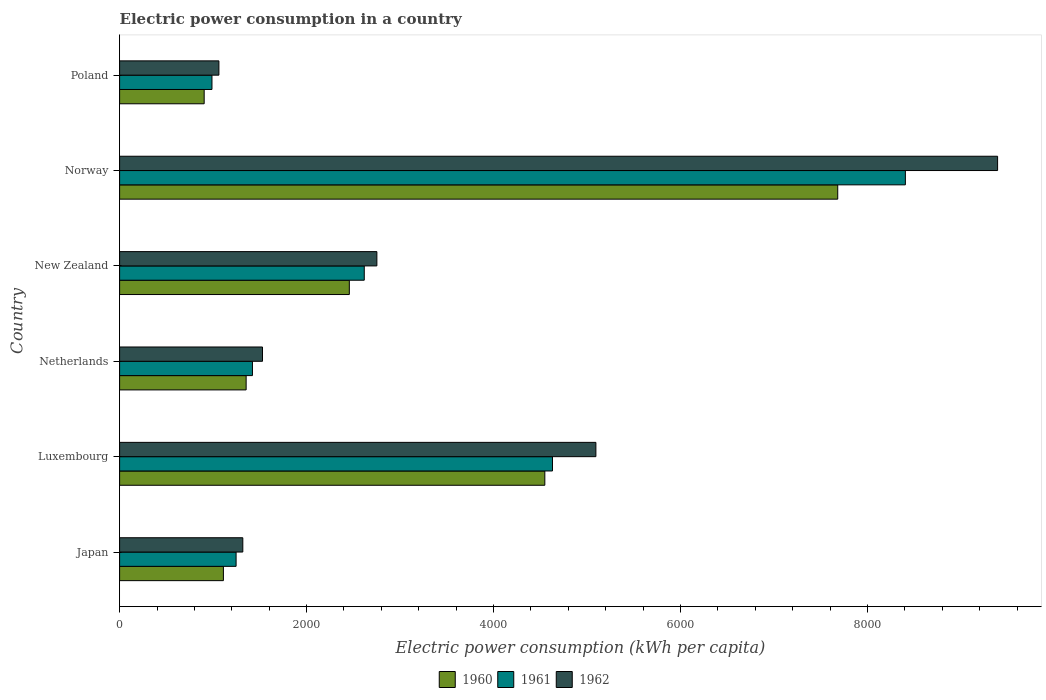How many groups of bars are there?
Give a very brief answer. 6. How many bars are there on the 5th tick from the top?
Keep it short and to the point. 3. How many bars are there on the 4th tick from the bottom?
Your answer should be compact. 3. What is the label of the 4th group of bars from the top?
Offer a very short reply. Netherlands. What is the electric power consumption in in 1960 in New Zealand?
Your answer should be very brief. 2457.21. Across all countries, what is the maximum electric power consumption in in 1960?
Provide a short and direct response. 7681.14. Across all countries, what is the minimum electric power consumption in in 1962?
Provide a short and direct response. 1062.18. What is the total electric power consumption in in 1960 in the graph?
Provide a short and direct response. 1.81e+04. What is the difference between the electric power consumption in in 1960 in Japan and that in Netherlands?
Offer a very short reply. -243.14. What is the difference between the electric power consumption in in 1962 in Luxembourg and the electric power consumption in in 1960 in Norway?
Make the answer very short. -2586.83. What is the average electric power consumption in in 1960 per country?
Your response must be concise. 3009.13. What is the difference between the electric power consumption in in 1961 and electric power consumption in in 1960 in Norway?
Offer a terse response. 723.48. In how many countries, is the electric power consumption in in 1962 greater than 3600 kWh per capita?
Offer a very short reply. 2. What is the ratio of the electric power consumption in in 1962 in Japan to that in Luxembourg?
Keep it short and to the point. 0.26. Is the electric power consumption in in 1961 in Netherlands less than that in New Zealand?
Provide a succinct answer. Yes. What is the difference between the highest and the second highest electric power consumption in in 1960?
Keep it short and to the point. 3132.94. What is the difference between the highest and the lowest electric power consumption in in 1962?
Make the answer very short. 8328.8. What does the 2nd bar from the top in Netherlands represents?
Your answer should be very brief. 1961. What does the 2nd bar from the bottom in Norway represents?
Your answer should be compact. 1961. How many countries are there in the graph?
Your answer should be compact. 6. Where does the legend appear in the graph?
Provide a succinct answer. Bottom center. What is the title of the graph?
Make the answer very short. Electric power consumption in a country. Does "1999" appear as one of the legend labels in the graph?
Your answer should be compact. No. What is the label or title of the X-axis?
Provide a short and direct response. Electric power consumption (kWh per capita). What is the Electric power consumption (kWh per capita) of 1960 in Japan?
Make the answer very short. 1110.26. What is the Electric power consumption (kWh per capita) of 1961 in Japan?
Your response must be concise. 1246.01. What is the Electric power consumption (kWh per capita) in 1962 in Japan?
Ensure brevity in your answer.  1317.93. What is the Electric power consumption (kWh per capita) of 1960 in Luxembourg?
Make the answer very short. 4548.21. What is the Electric power consumption (kWh per capita) in 1961 in Luxembourg?
Give a very brief answer. 4630.02. What is the Electric power consumption (kWh per capita) in 1962 in Luxembourg?
Offer a very short reply. 5094.31. What is the Electric power consumption (kWh per capita) in 1960 in Netherlands?
Keep it short and to the point. 1353.4. What is the Electric power consumption (kWh per capita) of 1961 in Netherlands?
Provide a short and direct response. 1421.03. What is the Electric power consumption (kWh per capita) of 1962 in Netherlands?
Keep it short and to the point. 1528.5. What is the Electric power consumption (kWh per capita) in 1960 in New Zealand?
Keep it short and to the point. 2457.21. What is the Electric power consumption (kWh per capita) of 1961 in New Zealand?
Your response must be concise. 2616.85. What is the Electric power consumption (kWh per capita) of 1962 in New Zealand?
Make the answer very short. 2751.81. What is the Electric power consumption (kWh per capita) in 1960 in Norway?
Your response must be concise. 7681.14. What is the Electric power consumption (kWh per capita) in 1961 in Norway?
Offer a very short reply. 8404.62. What is the Electric power consumption (kWh per capita) of 1962 in Norway?
Your answer should be very brief. 9390.98. What is the Electric power consumption (kWh per capita) of 1960 in Poland?
Offer a very short reply. 904.57. What is the Electric power consumption (kWh per capita) in 1961 in Poland?
Your response must be concise. 987.92. What is the Electric power consumption (kWh per capita) in 1962 in Poland?
Provide a succinct answer. 1062.18. Across all countries, what is the maximum Electric power consumption (kWh per capita) of 1960?
Offer a terse response. 7681.14. Across all countries, what is the maximum Electric power consumption (kWh per capita) of 1961?
Your response must be concise. 8404.62. Across all countries, what is the maximum Electric power consumption (kWh per capita) in 1962?
Your response must be concise. 9390.98. Across all countries, what is the minimum Electric power consumption (kWh per capita) of 1960?
Give a very brief answer. 904.57. Across all countries, what is the minimum Electric power consumption (kWh per capita) of 1961?
Make the answer very short. 987.92. Across all countries, what is the minimum Electric power consumption (kWh per capita) of 1962?
Your answer should be compact. 1062.18. What is the total Electric power consumption (kWh per capita) in 1960 in the graph?
Make the answer very short. 1.81e+04. What is the total Electric power consumption (kWh per capita) in 1961 in the graph?
Offer a very short reply. 1.93e+04. What is the total Electric power consumption (kWh per capita) of 1962 in the graph?
Provide a short and direct response. 2.11e+04. What is the difference between the Electric power consumption (kWh per capita) in 1960 in Japan and that in Luxembourg?
Keep it short and to the point. -3437.94. What is the difference between the Electric power consumption (kWh per capita) in 1961 in Japan and that in Luxembourg?
Keep it short and to the point. -3384.01. What is the difference between the Electric power consumption (kWh per capita) of 1962 in Japan and that in Luxembourg?
Offer a very short reply. -3776.38. What is the difference between the Electric power consumption (kWh per capita) of 1960 in Japan and that in Netherlands?
Keep it short and to the point. -243.14. What is the difference between the Electric power consumption (kWh per capita) in 1961 in Japan and that in Netherlands?
Ensure brevity in your answer.  -175.02. What is the difference between the Electric power consumption (kWh per capita) in 1962 in Japan and that in Netherlands?
Your answer should be very brief. -210.57. What is the difference between the Electric power consumption (kWh per capita) in 1960 in Japan and that in New Zealand?
Keep it short and to the point. -1346.94. What is the difference between the Electric power consumption (kWh per capita) of 1961 in Japan and that in New Zealand?
Your answer should be very brief. -1370.84. What is the difference between the Electric power consumption (kWh per capita) in 1962 in Japan and that in New Zealand?
Offer a terse response. -1433.88. What is the difference between the Electric power consumption (kWh per capita) of 1960 in Japan and that in Norway?
Make the answer very short. -6570.88. What is the difference between the Electric power consumption (kWh per capita) in 1961 in Japan and that in Norway?
Your answer should be very brief. -7158.61. What is the difference between the Electric power consumption (kWh per capita) in 1962 in Japan and that in Norway?
Offer a very short reply. -8073.05. What is the difference between the Electric power consumption (kWh per capita) of 1960 in Japan and that in Poland?
Provide a short and direct response. 205.7. What is the difference between the Electric power consumption (kWh per capita) in 1961 in Japan and that in Poland?
Keep it short and to the point. 258.09. What is the difference between the Electric power consumption (kWh per capita) in 1962 in Japan and that in Poland?
Your answer should be very brief. 255.75. What is the difference between the Electric power consumption (kWh per capita) in 1960 in Luxembourg and that in Netherlands?
Ensure brevity in your answer.  3194.81. What is the difference between the Electric power consumption (kWh per capita) in 1961 in Luxembourg and that in Netherlands?
Give a very brief answer. 3208.99. What is the difference between the Electric power consumption (kWh per capita) in 1962 in Luxembourg and that in Netherlands?
Provide a short and direct response. 3565.81. What is the difference between the Electric power consumption (kWh per capita) of 1960 in Luxembourg and that in New Zealand?
Give a very brief answer. 2091. What is the difference between the Electric power consumption (kWh per capita) of 1961 in Luxembourg and that in New Zealand?
Your answer should be very brief. 2013.17. What is the difference between the Electric power consumption (kWh per capita) in 1962 in Luxembourg and that in New Zealand?
Your answer should be very brief. 2342.5. What is the difference between the Electric power consumption (kWh per capita) of 1960 in Luxembourg and that in Norway?
Your answer should be very brief. -3132.94. What is the difference between the Electric power consumption (kWh per capita) in 1961 in Luxembourg and that in Norway?
Provide a succinct answer. -3774.6. What is the difference between the Electric power consumption (kWh per capita) of 1962 in Luxembourg and that in Norway?
Offer a very short reply. -4296.67. What is the difference between the Electric power consumption (kWh per capita) of 1960 in Luxembourg and that in Poland?
Provide a short and direct response. 3643.64. What is the difference between the Electric power consumption (kWh per capita) of 1961 in Luxembourg and that in Poland?
Give a very brief answer. 3642.11. What is the difference between the Electric power consumption (kWh per capita) of 1962 in Luxembourg and that in Poland?
Give a very brief answer. 4032.13. What is the difference between the Electric power consumption (kWh per capita) of 1960 in Netherlands and that in New Zealand?
Make the answer very short. -1103.81. What is the difference between the Electric power consumption (kWh per capita) in 1961 in Netherlands and that in New Zealand?
Offer a very short reply. -1195.82. What is the difference between the Electric power consumption (kWh per capita) of 1962 in Netherlands and that in New Zealand?
Ensure brevity in your answer.  -1223.31. What is the difference between the Electric power consumption (kWh per capita) in 1960 in Netherlands and that in Norway?
Your response must be concise. -6327.74. What is the difference between the Electric power consumption (kWh per capita) in 1961 in Netherlands and that in Norway?
Your answer should be compact. -6983.59. What is the difference between the Electric power consumption (kWh per capita) of 1962 in Netherlands and that in Norway?
Offer a very short reply. -7862.48. What is the difference between the Electric power consumption (kWh per capita) of 1960 in Netherlands and that in Poland?
Your response must be concise. 448.83. What is the difference between the Electric power consumption (kWh per capita) in 1961 in Netherlands and that in Poland?
Offer a very short reply. 433.11. What is the difference between the Electric power consumption (kWh per capita) in 1962 in Netherlands and that in Poland?
Make the answer very short. 466.32. What is the difference between the Electric power consumption (kWh per capita) in 1960 in New Zealand and that in Norway?
Your answer should be compact. -5223.94. What is the difference between the Electric power consumption (kWh per capita) in 1961 in New Zealand and that in Norway?
Keep it short and to the point. -5787.77. What is the difference between the Electric power consumption (kWh per capita) of 1962 in New Zealand and that in Norway?
Offer a terse response. -6639.17. What is the difference between the Electric power consumption (kWh per capita) of 1960 in New Zealand and that in Poland?
Make the answer very short. 1552.64. What is the difference between the Electric power consumption (kWh per capita) of 1961 in New Zealand and that in Poland?
Make the answer very short. 1628.93. What is the difference between the Electric power consumption (kWh per capita) of 1962 in New Zealand and that in Poland?
Give a very brief answer. 1689.64. What is the difference between the Electric power consumption (kWh per capita) in 1960 in Norway and that in Poland?
Give a very brief answer. 6776.58. What is the difference between the Electric power consumption (kWh per capita) in 1961 in Norway and that in Poland?
Your answer should be compact. 7416.7. What is the difference between the Electric power consumption (kWh per capita) of 1962 in Norway and that in Poland?
Ensure brevity in your answer.  8328.8. What is the difference between the Electric power consumption (kWh per capita) in 1960 in Japan and the Electric power consumption (kWh per capita) in 1961 in Luxembourg?
Offer a very short reply. -3519.76. What is the difference between the Electric power consumption (kWh per capita) of 1960 in Japan and the Electric power consumption (kWh per capita) of 1962 in Luxembourg?
Provide a short and direct response. -3984.05. What is the difference between the Electric power consumption (kWh per capita) in 1961 in Japan and the Electric power consumption (kWh per capita) in 1962 in Luxembourg?
Offer a very short reply. -3848.3. What is the difference between the Electric power consumption (kWh per capita) of 1960 in Japan and the Electric power consumption (kWh per capita) of 1961 in Netherlands?
Your answer should be very brief. -310.77. What is the difference between the Electric power consumption (kWh per capita) in 1960 in Japan and the Electric power consumption (kWh per capita) in 1962 in Netherlands?
Your answer should be very brief. -418.24. What is the difference between the Electric power consumption (kWh per capita) of 1961 in Japan and the Electric power consumption (kWh per capita) of 1962 in Netherlands?
Your answer should be very brief. -282.49. What is the difference between the Electric power consumption (kWh per capita) of 1960 in Japan and the Electric power consumption (kWh per capita) of 1961 in New Zealand?
Keep it short and to the point. -1506.59. What is the difference between the Electric power consumption (kWh per capita) of 1960 in Japan and the Electric power consumption (kWh per capita) of 1962 in New Zealand?
Offer a terse response. -1641.55. What is the difference between the Electric power consumption (kWh per capita) of 1961 in Japan and the Electric power consumption (kWh per capita) of 1962 in New Zealand?
Keep it short and to the point. -1505.8. What is the difference between the Electric power consumption (kWh per capita) of 1960 in Japan and the Electric power consumption (kWh per capita) of 1961 in Norway?
Provide a short and direct response. -7294.36. What is the difference between the Electric power consumption (kWh per capita) of 1960 in Japan and the Electric power consumption (kWh per capita) of 1962 in Norway?
Provide a succinct answer. -8280.71. What is the difference between the Electric power consumption (kWh per capita) in 1961 in Japan and the Electric power consumption (kWh per capita) in 1962 in Norway?
Offer a very short reply. -8144.97. What is the difference between the Electric power consumption (kWh per capita) in 1960 in Japan and the Electric power consumption (kWh per capita) in 1961 in Poland?
Give a very brief answer. 122.34. What is the difference between the Electric power consumption (kWh per capita) in 1960 in Japan and the Electric power consumption (kWh per capita) in 1962 in Poland?
Your response must be concise. 48.09. What is the difference between the Electric power consumption (kWh per capita) of 1961 in Japan and the Electric power consumption (kWh per capita) of 1962 in Poland?
Offer a very short reply. 183.83. What is the difference between the Electric power consumption (kWh per capita) in 1960 in Luxembourg and the Electric power consumption (kWh per capita) in 1961 in Netherlands?
Offer a terse response. 3127.17. What is the difference between the Electric power consumption (kWh per capita) in 1960 in Luxembourg and the Electric power consumption (kWh per capita) in 1962 in Netherlands?
Give a very brief answer. 3019.7. What is the difference between the Electric power consumption (kWh per capita) in 1961 in Luxembourg and the Electric power consumption (kWh per capita) in 1962 in Netherlands?
Ensure brevity in your answer.  3101.52. What is the difference between the Electric power consumption (kWh per capita) in 1960 in Luxembourg and the Electric power consumption (kWh per capita) in 1961 in New Zealand?
Your response must be concise. 1931.35. What is the difference between the Electric power consumption (kWh per capita) of 1960 in Luxembourg and the Electric power consumption (kWh per capita) of 1962 in New Zealand?
Provide a short and direct response. 1796.39. What is the difference between the Electric power consumption (kWh per capita) of 1961 in Luxembourg and the Electric power consumption (kWh per capita) of 1962 in New Zealand?
Your response must be concise. 1878.21. What is the difference between the Electric power consumption (kWh per capita) in 1960 in Luxembourg and the Electric power consumption (kWh per capita) in 1961 in Norway?
Provide a short and direct response. -3856.42. What is the difference between the Electric power consumption (kWh per capita) in 1960 in Luxembourg and the Electric power consumption (kWh per capita) in 1962 in Norway?
Provide a short and direct response. -4842.77. What is the difference between the Electric power consumption (kWh per capita) of 1961 in Luxembourg and the Electric power consumption (kWh per capita) of 1962 in Norway?
Make the answer very short. -4760.95. What is the difference between the Electric power consumption (kWh per capita) in 1960 in Luxembourg and the Electric power consumption (kWh per capita) in 1961 in Poland?
Offer a terse response. 3560.29. What is the difference between the Electric power consumption (kWh per capita) in 1960 in Luxembourg and the Electric power consumption (kWh per capita) in 1962 in Poland?
Make the answer very short. 3486.03. What is the difference between the Electric power consumption (kWh per capita) in 1961 in Luxembourg and the Electric power consumption (kWh per capita) in 1962 in Poland?
Your answer should be compact. 3567.85. What is the difference between the Electric power consumption (kWh per capita) of 1960 in Netherlands and the Electric power consumption (kWh per capita) of 1961 in New Zealand?
Ensure brevity in your answer.  -1263.45. What is the difference between the Electric power consumption (kWh per capita) in 1960 in Netherlands and the Electric power consumption (kWh per capita) in 1962 in New Zealand?
Provide a short and direct response. -1398.41. What is the difference between the Electric power consumption (kWh per capita) in 1961 in Netherlands and the Electric power consumption (kWh per capita) in 1962 in New Zealand?
Offer a very short reply. -1330.78. What is the difference between the Electric power consumption (kWh per capita) of 1960 in Netherlands and the Electric power consumption (kWh per capita) of 1961 in Norway?
Offer a very short reply. -7051.22. What is the difference between the Electric power consumption (kWh per capita) of 1960 in Netherlands and the Electric power consumption (kWh per capita) of 1962 in Norway?
Offer a very short reply. -8037.58. What is the difference between the Electric power consumption (kWh per capita) in 1961 in Netherlands and the Electric power consumption (kWh per capita) in 1962 in Norway?
Make the answer very short. -7969.94. What is the difference between the Electric power consumption (kWh per capita) in 1960 in Netherlands and the Electric power consumption (kWh per capita) in 1961 in Poland?
Your response must be concise. 365.48. What is the difference between the Electric power consumption (kWh per capita) of 1960 in Netherlands and the Electric power consumption (kWh per capita) of 1962 in Poland?
Give a very brief answer. 291.22. What is the difference between the Electric power consumption (kWh per capita) of 1961 in Netherlands and the Electric power consumption (kWh per capita) of 1962 in Poland?
Offer a very short reply. 358.86. What is the difference between the Electric power consumption (kWh per capita) of 1960 in New Zealand and the Electric power consumption (kWh per capita) of 1961 in Norway?
Give a very brief answer. -5947.42. What is the difference between the Electric power consumption (kWh per capita) of 1960 in New Zealand and the Electric power consumption (kWh per capita) of 1962 in Norway?
Offer a very short reply. -6933.77. What is the difference between the Electric power consumption (kWh per capita) in 1961 in New Zealand and the Electric power consumption (kWh per capita) in 1962 in Norway?
Your answer should be compact. -6774.12. What is the difference between the Electric power consumption (kWh per capita) of 1960 in New Zealand and the Electric power consumption (kWh per capita) of 1961 in Poland?
Ensure brevity in your answer.  1469.29. What is the difference between the Electric power consumption (kWh per capita) of 1960 in New Zealand and the Electric power consumption (kWh per capita) of 1962 in Poland?
Ensure brevity in your answer.  1395.03. What is the difference between the Electric power consumption (kWh per capita) of 1961 in New Zealand and the Electric power consumption (kWh per capita) of 1962 in Poland?
Make the answer very short. 1554.68. What is the difference between the Electric power consumption (kWh per capita) in 1960 in Norway and the Electric power consumption (kWh per capita) in 1961 in Poland?
Provide a short and direct response. 6693.22. What is the difference between the Electric power consumption (kWh per capita) in 1960 in Norway and the Electric power consumption (kWh per capita) in 1962 in Poland?
Provide a succinct answer. 6618.96. What is the difference between the Electric power consumption (kWh per capita) in 1961 in Norway and the Electric power consumption (kWh per capita) in 1962 in Poland?
Give a very brief answer. 7342.44. What is the average Electric power consumption (kWh per capita) in 1960 per country?
Provide a succinct answer. 3009.13. What is the average Electric power consumption (kWh per capita) in 1961 per country?
Keep it short and to the point. 3217.74. What is the average Electric power consumption (kWh per capita) of 1962 per country?
Your answer should be compact. 3524.29. What is the difference between the Electric power consumption (kWh per capita) of 1960 and Electric power consumption (kWh per capita) of 1961 in Japan?
Your answer should be compact. -135.75. What is the difference between the Electric power consumption (kWh per capita) of 1960 and Electric power consumption (kWh per capita) of 1962 in Japan?
Offer a very short reply. -207.67. What is the difference between the Electric power consumption (kWh per capita) of 1961 and Electric power consumption (kWh per capita) of 1962 in Japan?
Your answer should be very brief. -71.92. What is the difference between the Electric power consumption (kWh per capita) of 1960 and Electric power consumption (kWh per capita) of 1961 in Luxembourg?
Your answer should be compact. -81.82. What is the difference between the Electric power consumption (kWh per capita) in 1960 and Electric power consumption (kWh per capita) in 1962 in Luxembourg?
Your answer should be very brief. -546.11. What is the difference between the Electric power consumption (kWh per capita) of 1961 and Electric power consumption (kWh per capita) of 1962 in Luxembourg?
Provide a short and direct response. -464.29. What is the difference between the Electric power consumption (kWh per capita) of 1960 and Electric power consumption (kWh per capita) of 1961 in Netherlands?
Give a very brief answer. -67.63. What is the difference between the Electric power consumption (kWh per capita) in 1960 and Electric power consumption (kWh per capita) in 1962 in Netherlands?
Ensure brevity in your answer.  -175.1. What is the difference between the Electric power consumption (kWh per capita) in 1961 and Electric power consumption (kWh per capita) in 1962 in Netherlands?
Your answer should be compact. -107.47. What is the difference between the Electric power consumption (kWh per capita) in 1960 and Electric power consumption (kWh per capita) in 1961 in New Zealand?
Keep it short and to the point. -159.65. What is the difference between the Electric power consumption (kWh per capita) in 1960 and Electric power consumption (kWh per capita) in 1962 in New Zealand?
Provide a short and direct response. -294.61. What is the difference between the Electric power consumption (kWh per capita) of 1961 and Electric power consumption (kWh per capita) of 1962 in New Zealand?
Provide a succinct answer. -134.96. What is the difference between the Electric power consumption (kWh per capita) of 1960 and Electric power consumption (kWh per capita) of 1961 in Norway?
Make the answer very short. -723.48. What is the difference between the Electric power consumption (kWh per capita) of 1960 and Electric power consumption (kWh per capita) of 1962 in Norway?
Make the answer very short. -1709.84. What is the difference between the Electric power consumption (kWh per capita) in 1961 and Electric power consumption (kWh per capita) in 1962 in Norway?
Give a very brief answer. -986.36. What is the difference between the Electric power consumption (kWh per capita) in 1960 and Electric power consumption (kWh per capita) in 1961 in Poland?
Your response must be concise. -83.35. What is the difference between the Electric power consumption (kWh per capita) of 1960 and Electric power consumption (kWh per capita) of 1962 in Poland?
Give a very brief answer. -157.61. What is the difference between the Electric power consumption (kWh per capita) of 1961 and Electric power consumption (kWh per capita) of 1962 in Poland?
Your answer should be compact. -74.26. What is the ratio of the Electric power consumption (kWh per capita) of 1960 in Japan to that in Luxembourg?
Your answer should be compact. 0.24. What is the ratio of the Electric power consumption (kWh per capita) in 1961 in Japan to that in Luxembourg?
Provide a succinct answer. 0.27. What is the ratio of the Electric power consumption (kWh per capita) of 1962 in Japan to that in Luxembourg?
Your answer should be very brief. 0.26. What is the ratio of the Electric power consumption (kWh per capita) of 1960 in Japan to that in Netherlands?
Keep it short and to the point. 0.82. What is the ratio of the Electric power consumption (kWh per capita) of 1961 in Japan to that in Netherlands?
Ensure brevity in your answer.  0.88. What is the ratio of the Electric power consumption (kWh per capita) in 1962 in Japan to that in Netherlands?
Make the answer very short. 0.86. What is the ratio of the Electric power consumption (kWh per capita) of 1960 in Japan to that in New Zealand?
Ensure brevity in your answer.  0.45. What is the ratio of the Electric power consumption (kWh per capita) of 1961 in Japan to that in New Zealand?
Your answer should be very brief. 0.48. What is the ratio of the Electric power consumption (kWh per capita) of 1962 in Japan to that in New Zealand?
Ensure brevity in your answer.  0.48. What is the ratio of the Electric power consumption (kWh per capita) in 1960 in Japan to that in Norway?
Your answer should be very brief. 0.14. What is the ratio of the Electric power consumption (kWh per capita) in 1961 in Japan to that in Norway?
Offer a very short reply. 0.15. What is the ratio of the Electric power consumption (kWh per capita) in 1962 in Japan to that in Norway?
Your answer should be very brief. 0.14. What is the ratio of the Electric power consumption (kWh per capita) in 1960 in Japan to that in Poland?
Ensure brevity in your answer.  1.23. What is the ratio of the Electric power consumption (kWh per capita) of 1961 in Japan to that in Poland?
Your answer should be compact. 1.26. What is the ratio of the Electric power consumption (kWh per capita) of 1962 in Japan to that in Poland?
Give a very brief answer. 1.24. What is the ratio of the Electric power consumption (kWh per capita) in 1960 in Luxembourg to that in Netherlands?
Offer a terse response. 3.36. What is the ratio of the Electric power consumption (kWh per capita) in 1961 in Luxembourg to that in Netherlands?
Your answer should be compact. 3.26. What is the ratio of the Electric power consumption (kWh per capita) in 1962 in Luxembourg to that in Netherlands?
Your response must be concise. 3.33. What is the ratio of the Electric power consumption (kWh per capita) of 1960 in Luxembourg to that in New Zealand?
Your answer should be compact. 1.85. What is the ratio of the Electric power consumption (kWh per capita) of 1961 in Luxembourg to that in New Zealand?
Provide a succinct answer. 1.77. What is the ratio of the Electric power consumption (kWh per capita) of 1962 in Luxembourg to that in New Zealand?
Your answer should be very brief. 1.85. What is the ratio of the Electric power consumption (kWh per capita) in 1960 in Luxembourg to that in Norway?
Make the answer very short. 0.59. What is the ratio of the Electric power consumption (kWh per capita) in 1961 in Luxembourg to that in Norway?
Ensure brevity in your answer.  0.55. What is the ratio of the Electric power consumption (kWh per capita) of 1962 in Luxembourg to that in Norway?
Your answer should be compact. 0.54. What is the ratio of the Electric power consumption (kWh per capita) in 1960 in Luxembourg to that in Poland?
Your response must be concise. 5.03. What is the ratio of the Electric power consumption (kWh per capita) in 1961 in Luxembourg to that in Poland?
Make the answer very short. 4.69. What is the ratio of the Electric power consumption (kWh per capita) of 1962 in Luxembourg to that in Poland?
Your answer should be compact. 4.8. What is the ratio of the Electric power consumption (kWh per capita) of 1960 in Netherlands to that in New Zealand?
Your answer should be compact. 0.55. What is the ratio of the Electric power consumption (kWh per capita) in 1961 in Netherlands to that in New Zealand?
Make the answer very short. 0.54. What is the ratio of the Electric power consumption (kWh per capita) in 1962 in Netherlands to that in New Zealand?
Your response must be concise. 0.56. What is the ratio of the Electric power consumption (kWh per capita) in 1960 in Netherlands to that in Norway?
Provide a succinct answer. 0.18. What is the ratio of the Electric power consumption (kWh per capita) of 1961 in Netherlands to that in Norway?
Keep it short and to the point. 0.17. What is the ratio of the Electric power consumption (kWh per capita) of 1962 in Netherlands to that in Norway?
Give a very brief answer. 0.16. What is the ratio of the Electric power consumption (kWh per capita) of 1960 in Netherlands to that in Poland?
Your answer should be compact. 1.5. What is the ratio of the Electric power consumption (kWh per capita) of 1961 in Netherlands to that in Poland?
Keep it short and to the point. 1.44. What is the ratio of the Electric power consumption (kWh per capita) in 1962 in Netherlands to that in Poland?
Keep it short and to the point. 1.44. What is the ratio of the Electric power consumption (kWh per capita) of 1960 in New Zealand to that in Norway?
Your answer should be compact. 0.32. What is the ratio of the Electric power consumption (kWh per capita) of 1961 in New Zealand to that in Norway?
Give a very brief answer. 0.31. What is the ratio of the Electric power consumption (kWh per capita) of 1962 in New Zealand to that in Norway?
Your response must be concise. 0.29. What is the ratio of the Electric power consumption (kWh per capita) of 1960 in New Zealand to that in Poland?
Make the answer very short. 2.72. What is the ratio of the Electric power consumption (kWh per capita) of 1961 in New Zealand to that in Poland?
Provide a short and direct response. 2.65. What is the ratio of the Electric power consumption (kWh per capita) of 1962 in New Zealand to that in Poland?
Provide a short and direct response. 2.59. What is the ratio of the Electric power consumption (kWh per capita) in 1960 in Norway to that in Poland?
Offer a very short reply. 8.49. What is the ratio of the Electric power consumption (kWh per capita) of 1961 in Norway to that in Poland?
Provide a succinct answer. 8.51. What is the ratio of the Electric power consumption (kWh per capita) of 1962 in Norway to that in Poland?
Ensure brevity in your answer.  8.84. What is the difference between the highest and the second highest Electric power consumption (kWh per capita) of 1960?
Make the answer very short. 3132.94. What is the difference between the highest and the second highest Electric power consumption (kWh per capita) of 1961?
Offer a terse response. 3774.6. What is the difference between the highest and the second highest Electric power consumption (kWh per capita) of 1962?
Your response must be concise. 4296.67. What is the difference between the highest and the lowest Electric power consumption (kWh per capita) in 1960?
Give a very brief answer. 6776.58. What is the difference between the highest and the lowest Electric power consumption (kWh per capita) in 1961?
Your response must be concise. 7416.7. What is the difference between the highest and the lowest Electric power consumption (kWh per capita) in 1962?
Your answer should be compact. 8328.8. 